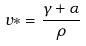<formula> <loc_0><loc_0><loc_500><loc_500>v * = \frac { \gamma + \alpha } { \rho }</formula> 